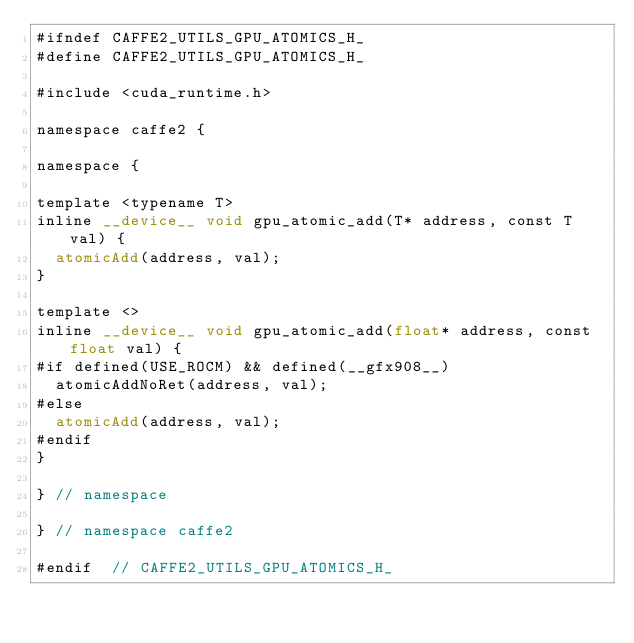<code> <loc_0><loc_0><loc_500><loc_500><_Cuda_>#ifndef CAFFE2_UTILS_GPU_ATOMICS_H_
#define CAFFE2_UTILS_GPU_ATOMICS_H_

#include <cuda_runtime.h>

namespace caffe2 {

namespace {

template <typename T>
inline __device__ void gpu_atomic_add(T* address, const T val) {
  atomicAdd(address, val);
}

template <>
inline __device__ void gpu_atomic_add(float* address, const float val) {
#if defined(USE_ROCM) && defined(__gfx908__)
  atomicAddNoRet(address, val);
#else
  atomicAdd(address, val);
#endif
}

} // namespace

} // namespace caffe2

#endif  // CAFFE2_UTILS_GPU_ATOMICS_H_
</code> 